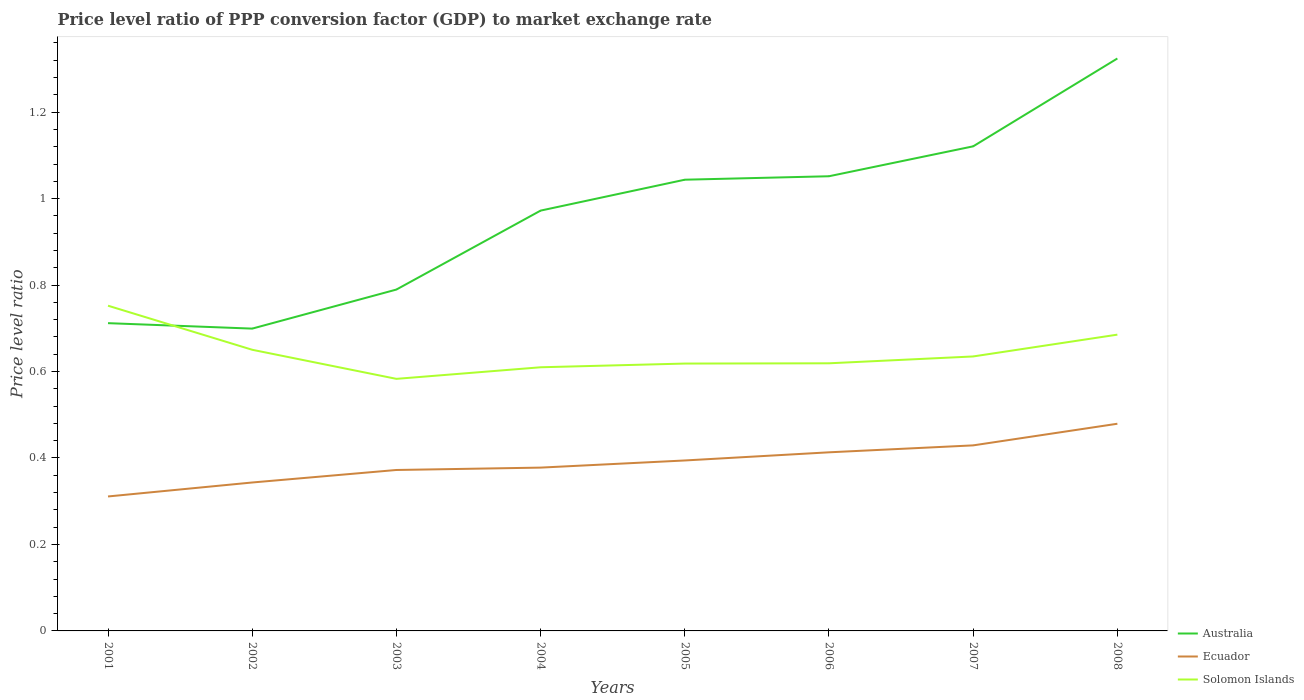How many different coloured lines are there?
Provide a succinct answer. 3. Does the line corresponding to Australia intersect with the line corresponding to Ecuador?
Offer a very short reply. No. Across all years, what is the maximum price level ratio in Ecuador?
Give a very brief answer. 0.31. In which year was the price level ratio in Solomon Islands maximum?
Make the answer very short. 2003. What is the total price level ratio in Ecuador in the graph?
Provide a short and direct response. -0.05. What is the difference between the highest and the second highest price level ratio in Solomon Islands?
Offer a terse response. 0.17. Is the price level ratio in Australia strictly greater than the price level ratio in Ecuador over the years?
Your answer should be very brief. No. Does the graph contain any zero values?
Provide a short and direct response. No. Where does the legend appear in the graph?
Give a very brief answer. Bottom right. How are the legend labels stacked?
Your answer should be very brief. Vertical. What is the title of the graph?
Give a very brief answer. Price level ratio of PPP conversion factor (GDP) to market exchange rate. Does "Hong Kong" appear as one of the legend labels in the graph?
Offer a very short reply. No. What is the label or title of the X-axis?
Ensure brevity in your answer.  Years. What is the label or title of the Y-axis?
Provide a succinct answer. Price level ratio. What is the Price level ratio in Australia in 2001?
Make the answer very short. 0.71. What is the Price level ratio of Ecuador in 2001?
Offer a terse response. 0.31. What is the Price level ratio of Solomon Islands in 2001?
Keep it short and to the point. 0.75. What is the Price level ratio in Australia in 2002?
Your answer should be very brief. 0.7. What is the Price level ratio in Ecuador in 2002?
Your answer should be very brief. 0.34. What is the Price level ratio in Solomon Islands in 2002?
Offer a terse response. 0.65. What is the Price level ratio in Australia in 2003?
Your response must be concise. 0.79. What is the Price level ratio of Ecuador in 2003?
Make the answer very short. 0.37. What is the Price level ratio of Solomon Islands in 2003?
Your response must be concise. 0.58. What is the Price level ratio in Australia in 2004?
Make the answer very short. 0.97. What is the Price level ratio of Ecuador in 2004?
Provide a succinct answer. 0.38. What is the Price level ratio of Solomon Islands in 2004?
Provide a succinct answer. 0.61. What is the Price level ratio of Australia in 2005?
Keep it short and to the point. 1.04. What is the Price level ratio of Ecuador in 2005?
Provide a succinct answer. 0.39. What is the Price level ratio in Solomon Islands in 2005?
Give a very brief answer. 0.62. What is the Price level ratio of Australia in 2006?
Provide a succinct answer. 1.05. What is the Price level ratio of Ecuador in 2006?
Your response must be concise. 0.41. What is the Price level ratio of Solomon Islands in 2006?
Keep it short and to the point. 0.62. What is the Price level ratio of Australia in 2007?
Give a very brief answer. 1.12. What is the Price level ratio of Ecuador in 2007?
Keep it short and to the point. 0.43. What is the Price level ratio of Solomon Islands in 2007?
Offer a very short reply. 0.63. What is the Price level ratio of Australia in 2008?
Your answer should be compact. 1.32. What is the Price level ratio in Ecuador in 2008?
Keep it short and to the point. 0.48. What is the Price level ratio of Solomon Islands in 2008?
Offer a very short reply. 0.69. Across all years, what is the maximum Price level ratio of Australia?
Provide a short and direct response. 1.32. Across all years, what is the maximum Price level ratio in Ecuador?
Offer a very short reply. 0.48. Across all years, what is the maximum Price level ratio of Solomon Islands?
Your response must be concise. 0.75. Across all years, what is the minimum Price level ratio in Australia?
Give a very brief answer. 0.7. Across all years, what is the minimum Price level ratio of Ecuador?
Your answer should be compact. 0.31. Across all years, what is the minimum Price level ratio of Solomon Islands?
Make the answer very short. 0.58. What is the total Price level ratio in Australia in the graph?
Your answer should be very brief. 7.71. What is the total Price level ratio of Ecuador in the graph?
Your response must be concise. 3.12. What is the total Price level ratio in Solomon Islands in the graph?
Your response must be concise. 5.15. What is the difference between the Price level ratio of Australia in 2001 and that in 2002?
Your answer should be very brief. 0.01. What is the difference between the Price level ratio of Ecuador in 2001 and that in 2002?
Make the answer very short. -0.03. What is the difference between the Price level ratio of Solomon Islands in 2001 and that in 2002?
Your answer should be very brief. 0.1. What is the difference between the Price level ratio in Australia in 2001 and that in 2003?
Make the answer very short. -0.08. What is the difference between the Price level ratio in Ecuador in 2001 and that in 2003?
Keep it short and to the point. -0.06. What is the difference between the Price level ratio of Solomon Islands in 2001 and that in 2003?
Make the answer very short. 0.17. What is the difference between the Price level ratio in Australia in 2001 and that in 2004?
Your response must be concise. -0.26. What is the difference between the Price level ratio in Ecuador in 2001 and that in 2004?
Your response must be concise. -0.07. What is the difference between the Price level ratio in Solomon Islands in 2001 and that in 2004?
Your answer should be very brief. 0.14. What is the difference between the Price level ratio in Australia in 2001 and that in 2005?
Your answer should be compact. -0.33. What is the difference between the Price level ratio in Ecuador in 2001 and that in 2005?
Your answer should be compact. -0.08. What is the difference between the Price level ratio of Solomon Islands in 2001 and that in 2005?
Provide a short and direct response. 0.13. What is the difference between the Price level ratio in Australia in 2001 and that in 2006?
Offer a terse response. -0.34. What is the difference between the Price level ratio in Ecuador in 2001 and that in 2006?
Provide a succinct answer. -0.1. What is the difference between the Price level ratio in Solomon Islands in 2001 and that in 2006?
Offer a very short reply. 0.13. What is the difference between the Price level ratio in Australia in 2001 and that in 2007?
Ensure brevity in your answer.  -0.41. What is the difference between the Price level ratio in Ecuador in 2001 and that in 2007?
Make the answer very short. -0.12. What is the difference between the Price level ratio of Solomon Islands in 2001 and that in 2007?
Keep it short and to the point. 0.12. What is the difference between the Price level ratio in Australia in 2001 and that in 2008?
Provide a short and direct response. -0.61. What is the difference between the Price level ratio of Ecuador in 2001 and that in 2008?
Keep it short and to the point. -0.17. What is the difference between the Price level ratio in Solomon Islands in 2001 and that in 2008?
Your answer should be very brief. 0.07. What is the difference between the Price level ratio in Australia in 2002 and that in 2003?
Offer a very short reply. -0.09. What is the difference between the Price level ratio of Ecuador in 2002 and that in 2003?
Offer a very short reply. -0.03. What is the difference between the Price level ratio in Solomon Islands in 2002 and that in 2003?
Ensure brevity in your answer.  0.07. What is the difference between the Price level ratio in Australia in 2002 and that in 2004?
Keep it short and to the point. -0.27. What is the difference between the Price level ratio of Ecuador in 2002 and that in 2004?
Make the answer very short. -0.03. What is the difference between the Price level ratio in Solomon Islands in 2002 and that in 2004?
Offer a very short reply. 0.04. What is the difference between the Price level ratio in Australia in 2002 and that in 2005?
Ensure brevity in your answer.  -0.34. What is the difference between the Price level ratio in Ecuador in 2002 and that in 2005?
Ensure brevity in your answer.  -0.05. What is the difference between the Price level ratio in Solomon Islands in 2002 and that in 2005?
Your answer should be compact. 0.03. What is the difference between the Price level ratio of Australia in 2002 and that in 2006?
Provide a succinct answer. -0.35. What is the difference between the Price level ratio of Ecuador in 2002 and that in 2006?
Your answer should be very brief. -0.07. What is the difference between the Price level ratio of Solomon Islands in 2002 and that in 2006?
Make the answer very short. 0.03. What is the difference between the Price level ratio in Australia in 2002 and that in 2007?
Give a very brief answer. -0.42. What is the difference between the Price level ratio in Ecuador in 2002 and that in 2007?
Ensure brevity in your answer.  -0.09. What is the difference between the Price level ratio of Solomon Islands in 2002 and that in 2007?
Offer a terse response. 0.02. What is the difference between the Price level ratio in Australia in 2002 and that in 2008?
Provide a succinct answer. -0.62. What is the difference between the Price level ratio of Ecuador in 2002 and that in 2008?
Ensure brevity in your answer.  -0.14. What is the difference between the Price level ratio of Solomon Islands in 2002 and that in 2008?
Keep it short and to the point. -0.04. What is the difference between the Price level ratio of Australia in 2003 and that in 2004?
Provide a short and direct response. -0.18. What is the difference between the Price level ratio in Ecuador in 2003 and that in 2004?
Your response must be concise. -0.01. What is the difference between the Price level ratio of Solomon Islands in 2003 and that in 2004?
Keep it short and to the point. -0.03. What is the difference between the Price level ratio of Australia in 2003 and that in 2005?
Give a very brief answer. -0.25. What is the difference between the Price level ratio in Ecuador in 2003 and that in 2005?
Keep it short and to the point. -0.02. What is the difference between the Price level ratio in Solomon Islands in 2003 and that in 2005?
Provide a short and direct response. -0.04. What is the difference between the Price level ratio of Australia in 2003 and that in 2006?
Your response must be concise. -0.26. What is the difference between the Price level ratio of Ecuador in 2003 and that in 2006?
Provide a succinct answer. -0.04. What is the difference between the Price level ratio of Solomon Islands in 2003 and that in 2006?
Offer a very short reply. -0.04. What is the difference between the Price level ratio in Australia in 2003 and that in 2007?
Provide a succinct answer. -0.33. What is the difference between the Price level ratio of Ecuador in 2003 and that in 2007?
Offer a terse response. -0.06. What is the difference between the Price level ratio of Solomon Islands in 2003 and that in 2007?
Offer a terse response. -0.05. What is the difference between the Price level ratio in Australia in 2003 and that in 2008?
Keep it short and to the point. -0.53. What is the difference between the Price level ratio in Ecuador in 2003 and that in 2008?
Ensure brevity in your answer.  -0.11. What is the difference between the Price level ratio in Solomon Islands in 2003 and that in 2008?
Keep it short and to the point. -0.1. What is the difference between the Price level ratio of Australia in 2004 and that in 2005?
Give a very brief answer. -0.07. What is the difference between the Price level ratio of Ecuador in 2004 and that in 2005?
Give a very brief answer. -0.02. What is the difference between the Price level ratio in Solomon Islands in 2004 and that in 2005?
Your answer should be very brief. -0.01. What is the difference between the Price level ratio of Australia in 2004 and that in 2006?
Give a very brief answer. -0.08. What is the difference between the Price level ratio of Ecuador in 2004 and that in 2006?
Give a very brief answer. -0.04. What is the difference between the Price level ratio of Solomon Islands in 2004 and that in 2006?
Give a very brief answer. -0.01. What is the difference between the Price level ratio of Australia in 2004 and that in 2007?
Give a very brief answer. -0.15. What is the difference between the Price level ratio in Ecuador in 2004 and that in 2007?
Give a very brief answer. -0.05. What is the difference between the Price level ratio of Solomon Islands in 2004 and that in 2007?
Make the answer very short. -0.03. What is the difference between the Price level ratio in Australia in 2004 and that in 2008?
Give a very brief answer. -0.35. What is the difference between the Price level ratio of Ecuador in 2004 and that in 2008?
Your response must be concise. -0.1. What is the difference between the Price level ratio in Solomon Islands in 2004 and that in 2008?
Provide a short and direct response. -0.08. What is the difference between the Price level ratio in Australia in 2005 and that in 2006?
Offer a terse response. -0.01. What is the difference between the Price level ratio of Ecuador in 2005 and that in 2006?
Provide a short and direct response. -0.02. What is the difference between the Price level ratio in Solomon Islands in 2005 and that in 2006?
Ensure brevity in your answer.  -0. What is the difference between the Price level ratio of Australia in 2005 and that in 2007?
Offer a very short reply. -0.08. What is the difference between the Price level ratio in Ecuador in 2005 and that in 2007?
Make the answer very short. -0.03. What is the difference between the Price level ratio of Solomon Islands in 2005 and that in 2007?
Your answer should be very brief. -0.02. What is the difference between the Price level ratio of Australia in 2005 and that in 2008?
Offer a terse response. -0.28. What is the difference between the Price level ratio in Ecuador in 2005 and that in 2008?
Ensure brevity in your answer.  -0.08. What is the difference between the Price level ratio of Solomon Islands in 2005 and that in 2008?
Keep it short and to the point. -0.07. What is the difference between the Price level ratio of Australia in 2006 and that in 2007?
Ensure brevity in your answer.  -0.07. What is the difference between the Price level ratio in Ecuador in 2006 and that in 2007?
Give a very brief answer. -0.02. What is the difference between the Price level ratio in Solomon Islands in 2006 and that in 2007?
Your answer should be compact. -0.02. What is the difference between the Price level ratio of Australia in 2006 and that in 2008?
Provide a short and direct response. -0.27. What is the difference between the Price level ratio in Ecuador in 2006 and that in 2008?
Make the answer very short. -0.07. What is the difference between the Price level ratio of Solomon Islands in 2006 and that in 2008?
Make the answer very short. -0.07. What is the difference between the Price level ratio in Australia in 2007 and that in 2008?
Provide a short and direct response. -0.2. What is the difference between the Price level ratio in Solomon Islands in 2007 and that in 2008?
Offer a terse response. -0.05. What is the difference between the Price level ratio in Australia in 2001 and the Price level ratio in Ecuador in 2002?
Give a very brief answer. 0.37. What is the difference between the Price level ratio in Australia in 2001 and the Price level ratio in Solomon Islands in 2002?
Provide a succinct answer. 0.06. What is the difference between the Price level ratio of Ecuador in 2001 and the Price level ratio of Solomon Islands in 2002?
Your answer should be very brief. -0.34. What is the difference between the Price level ratio in Australia in 2001 and the Price level ratio in Ecuador in 2003?
Make the answer very short. 0.34. What is the difference between the Price level ratio in Australia in 2001 and the Price level ratio in Solomon Islands in 2003?
Give a very brief answer. 0.13. What is the difference between the Price level ratio in Ecuador in 2001 and the Price level ratio in Solomon Islands in 2003?
Offer a terse response. -0.27. What is the difference between the Price level ratio of Australia in 2001 and the Price level ratio of Ecuador in 2004?
Offer a terse response. 0.33. What is the difference between the Price level ratio of Australia in 2001 and the Price level ratio of Solomon Islands in 2004?
Make the answer very short. 0.1. What is the difference between the Price level ratio in Ecuador in 2001 and the Price level ratio in Solomon Islands in 2004?
Provide a short and direct response. -0.3. What is the difference between the Price level ratio in Australia in 2001 and the Price level ratio in Ecuador in 2005?
Offer a terse response. 0.32. What is the difference between the Price level ratio in Australia in 2001 and the Price level ratio in Solomon Islands in 2005?
Provide a succinct answer. 0.09. What is the difference between the Price level ratio of Ecuador in 2001 and the Price level ratio of Solomon Islands in 2005?
Give a very brief answer. -0.31. What is the difference between the Price level ratio of Australia in 2001 and the Price level ratio of Ecuador in 2006?
Offer a very short reply. 0.3. What is the difference between the Price level ratio of Australia in 2001 and the Price level ratio of Solomon Islands in 2006?
Your answer should be compact. 0.09. What is the difference between the Price level ratio of Ecuador in 2001 and the Price level ratio of Solomon Islands in 2006?
Your answer should be compact. -0.31. What is the difference between the Price level ratio of Australia in 2001 and the Price level ratio of Ecuador in 2007?
Provide a succinct answer. 0.28. What is the difference between the Price level ratio of Australia in 2001 and the Price level ratio of Solomon Islands in 2007?
Your answer should be very brief. 0.08. What is the difference between the Price level ratio in Ecuador in 2001 and the Price level ratio in Solomon Islands in 2007?
Give a very brief answer. -0.32. What is the difference between the Price level ratio in Australia in 2001 and the Price level ratio in Ecuador in 2008?
Ensure brevity in your answer.  0.23. What is the difference between the Price level ratio of Australia in 2001 and the Price level ratio of Solomon Islands in 2008?
Your answer should be very brief. 0.03. What is the difference between the Price level ratio of Ecuador in 2001 and the Price level ratio of Solomon Islands in 2008?
Your response must be concise. -0.37. What is the difference between the Price level ratio in Australia in 2002 and the Price level ratio in Ecuador in 2003?
Make the answer very short. 0.33. What is the difference between the Price level ratio in Australia in 2002 and the Price level ratio in Solomon Islands in 2003?
Offer a terse response. 0.12. What is the difference between the Price level ratio in Ecuador in 2002 and the Price level ratio in Solomon Islands in 2003?
Your answer should be very brief. -0.24. What is the difference between the Price level ratio in Australia in 2002 and the Price level ratio in Ecuador in 2004?
Offer a terse response. 0.32. What is the difference between the Price level ratio in Australia in 2002 and the Price level ratio in Solomon Islands in 2004?
Provide a short and direct response. 0.09. What is the difference between the Price level ratio in Ecuador in 2002 and the Price level ratio in Solomon Islands in 2004?
Give a very brief answer. -0.27. What is the difference between the Price level ratio in Australia in 2002 and the Price level ratio in Ecuador in 2005?
Your answer should be very brief. 0.3. What is the difference between the Price level ratio of Australia in 2002 and the Price level ratio of Solomon Islands in 2005?
Offer a terse response. 0.08. What is the difference between the Price level ratio in Ecuador in 2002 and the Price level ratio in Solomon Islands in 2005?
Your response must be concise. -0.28. What is the difference between the Price level ratio of Australia in 2002 and the Price level ratio of Ecuador in 2006?
Offer a terse response. 0.29. What is the difference between the Price level ratio of Australia in 2002 and the Price level ratio of Solomon Islands in 2006?
Offer a very short reply. 0.08. What is the difference between the Price level ratio of Ecuador in 2002 and the Price level ratio of Solomon Islands in 2006?
Offer a very short reply. -0.28. What is the difference between the Price level ratio of Australia in 2002 and the Price level ratio of Ecuador in 2007?
Ensure brevity in your answer.  0.27. What is the difference between the Price level ratio in Australia in 2002 and the Price level ratio in Solomon Islands in 2007?
Offer a terse response. 0.06. What is the difference between the Price level ratio of Ecuador in 2002 and the Price level ratio of Solomon Islands in 2007?
Ensure brevity in your answer.  -0.29. What is the difference between the Price level ratio of Australia in 2002 and the Price level ratio of Ecuador in 2008?
Offer a very short reply. 0.22. What is the difference between the Price level ratio in Australia in 2002 and the Price level ratio in Solomon Islands in 2008?
Provide a succinct answer. 0.01. What is the difference between the Price level ratio in Ecuador in 2002 and the Price level ratio in Solomon Islands in 2008?
Offer a very short reply. -0.34. What is the difference between the Price level ratio of Australia in 2003 and the Price level ratio of Ecuador in 2004?
Your response must be concise. 0.41. What is the difference between the Price level ratio in Australia in 2003 and the Price level ratio in Solomon Islands in 2004?
Offer a terse response. 0.18. What is the difference between the Price level ratio in Ecuador in 2003 and the Price level ratio in Solomon Islands in 2004?
Keep it short and to the point. -0.24. What is the difference between the Price level ratio of Australia in 2003 and the Price level ratio of Ecuador in 2005?
Provide a short and direct response. 0.4. What is the difference between the Price level ratio of Australia in 2003 and the Price level ratio of Solomon Islands in 2005?
Your response must be concise. 0.17. What is the difference between the Price level ratio of Ecuador in 2003 and the Price level ratio of Solomon Islands in 2005?
Your response must be concise. -0.25. What is the difference between the Price level ratio in Australia in 2003 and the Price level ratio in Ecuador in 2006?
Ensure brevity in your answer.  0.38. What is the difference between the Price level ratio of Australia in 2003 and the Price level ratio of Solomon Islands in 2006?
Ensure brevity in your answer.  0.17. What is the difference between the Price level ratio of Ecuador in 2003 and the Price level ratio of Solomon Islands in 2006?
Keep it short and to the point. -0.25. What is the difference between the Price level ratio of Australia in 2003 and the Price level ratio of Ecuador in 2007?
Keep it short and to the point. 0.36. What is the difference between the Price level ratio of Australia in 2003 and the Price level ratio of Solomon Islands in 2007?
Provide a succinct answer. 0.15. What is the difference between the Price level ratio of Ecuador in 2003 and the Price level ratio of Solomon Islands in 2007?
Offer a very short reply. -0.26. What is the difference between the Price level ratio in Australia in 2003 and the Price level ratio in Ecuador in 2008?
Offer a very short reply. 0.31. What is the difference between the Price level ratio in Australia in 2003 and the Price level ratio in Solomon Islands in 2008?
Ensure brevity in your answer.  0.1. What is the difference between the Price level ratio in Ecuador in 2003 and the Price level ratio in Solomon Islands in 2008?
Offer a very short reply. -0.31. What is the difference between the Price level ratio in Australia in 2004 and the Price level ratio in Ecuador in 2005?
Your answer should be very brief. 0.58. What is the difference between the Price level ratio in Australia in 2004 and the Price level ratio in Solomon Islands in 2005?
Provide a succinct answer. 0.35. What is the difference between the Price level ratio of Ecuador in 2004 and the Price level ratio of Solomon Islands in 2005?
Give a very brief answer. -0.24. What is the difference between the Price level ratio of Australia in 2004 and the Price level ratio of Ecuador in 2006?
Your response must be concise. 0.56. What is the difference between the Price level ratio of Australia in 2004 and the Price level ratio of Solomon Islands in 2006?
Offer a terse response. 0.35. What is the difference between the Price level ratio in Ecuador in 2004 and the Price level ratio in Solomon Islands in 2006?
Provide a short and direct response. -0.24. What is the difference between the Price level ratio in Australia in 2004 and the Price level ratio in Ecuador in 2007?
Offer a very short reply. 0.54. What is the difference between the Price level ratio of Australia in 2004 and the Price level ratio of Solomon Islands in 2007?
Provide a succinct answer. 0.34. What is the difference between the Price level ratio of Ecuador in 2004 and the Price level ratio of Solomon Islands in 2007?
Your response must be concise. -0.26. What is the difference between the Price level ratio of Australia in 2004 and the Price level ratio of Ecuador in 2008?
Give a very brief answer. 0.49. What is the difference between the Price level ratio of Australia in 2004 and the Price level ratio of Solomon Islands in 2008?
Provide a succinct answer. 0.29. What is the difference between the Price level ratio in Ecuador in 2004 and the Price level ratio in Solomon Islands in 2008?
Provide a succinct answer. -0.31. What is the difference between the Price level ratio of Australia in 2005 and the Price level ratio of Ecuador in 2006?
Ensure brevity in your answer.  0.63. What is the difference between the Price level ratio of Australia in 2005 and the Price level ratio of Solomon Islands in 2006?
Give a very brief answer. 0.42. What is the difference between the Price level ratio in Ecuador in 2005 and the Price level ratio in Solomon Islands in 2006?
Make the answer very short. -0.22. What is the difference between the Price level ratio in Australia in 2005 and the Price level ratio in Ecuador in 2007?
Make the answer very short. 0.61. What is the difference between the Price level ratio of Australia in 2005 and the Price level ratio of Solomon Islands in 2007?
Provide a short and direct response. 0.41. What is the difference between the Price level ratio of Ecuador in 2005 and the Price level ratio of Solomon Islands in 2007?
Your response must be concise. -0.24. What is the difference between the Price level ratio in Australia in 2005 and the Price level ratio in Ecuador in 2008?
Ensure brevity in your answer.  0.56. What is the difference between the Price level ratio of Australia in 2005 and the Price level ratio of Solomon Islands in 2008?
Your answer should be compact. 0.36. What is the difference between the Price level ratio in Ecuador in 2005 and the Price level ratio in Solomon Islands in 2008?
Provide a short and direct response. -0.29. What is the difference between the Price level ratio in Australia in 2006 and the Price level ratio in Ecuador in 2007?
Keep it short and to the point. 0.62. What is the difference between the Price level ratio of Australia in 2006 and the Price level ratio of Solomon Islands in 2007?
Your response must be concise. 0.42. What is the difference between the Price level ratio in Ecuador in 2006 and the Price level ratio in Solomon Islands in 2007?
Your answer should be very brief. -0.22. What is the difference between the Price level ratio in Australia in 2006 and the Price level ratio in Ecuador in 2008?
Offer a very short reply. 0.57. What is the difference between the Price level ratio in Australia in 2006 and the Price level ratio in Solomon Islands in 2008?
Provide a succinct answer. 0.37. What is the difference between the Price level ratio of Ecuador in 2006 and the Price level ratio of Solomon Islands in 2008?
Keep it short and to the point. -0.27. What is the difference between the Price level ratio of Australia in 2007 and the Price level ratio of Ecuador in 2008?
Give a very brief answer. 0.64. What is the difference between the Price level ratio of Australia in 2007 and the Price level ratio of Solomon Islands in 2008?
Give a very brief answer. 0.44. What is the difference between the Price level ratio in Ecuador in 2007 and the Price level ratio in Solomon Islands in 2008?
Offer a terse response. -0.26. What is the average Price level ratio of Australia per year?
Give a very brief answer. 0.96. What is the average Price level ratio of Ecuador per year?
Provide a short and direct response. 0.39. What is the average Price level ratio in Solomon Islands per year?
Offer a terse response. 0.64. In the year 2001, what is the difference between the Price level ratio of Australia and Price level ratio of Ecuador?
Offer a terse response. 0.4. In the year 2001, what is the difference between the Price level ratio of Australia and Price level ratio of Solomon Islands?
Provide a short and direct response. -0.04. In the year 2001, what is the difference between the Price level ratio in Ecuador and Price level ratio in Solomon Islands?
Make the answer very short. -0.44. In the year 2002, what is the difference between the Price level ratio of Australia and Price level ratio of Ecuador?
Your answer should be very brief. 0.36. In the year 2002, what is the difference between the Price level ratio in Australia and Price level ratio in Solomon Islands?
Provide a succinct answer. 0.05. In the year 2002, what is the difference between the Price level ratio in Ecuador and Price level ratio in Solomon Islands?
Your response must be concise. -0.31. In the year 2003, what is the difference between the Price level ratio of Australia and Price level ratio of Ecuador?
Keep it short and to the point. 0.42. In the year 2003, what is the difference between the Price level ratio of Australia and Price level ratio of Solomon Islands?
Your response must be concise. 0.21. In the year 2003, what is the difference between the Price level ratio in Ecuador and Price level ratio in Solomon Islands?
Provide a succinct answer. -0.21. In the year 2004, what is the difference between the Price level ratio in Australia and Price level ratio in Ecuador?
Offer a very short reply. 0.59. In the year 2004, what is the difference between the Price level ratio of Australia and Price level ratio of Solomon Islands?
Give a very brief answer. 0.36. In the year 2004, what is the difference between the Price level ratio in Ecuador and Price level ratio in Solomon Islands?
Your answer should be compact. -0.23. In the year 2005, what is the difference between the Price level ratio in Australia and Price level ratio in Ecuador?
Give a very brief answer. 0.65. In the year 2005, what is the difference between the Price level ratio of Australia and Price level ratio of Solomon Islands?
Keep it short and to the point. 0.43. In the year 2005, what is the difference between the Price level ratio in Ecuador and Price level ratio in Solomon Islands?
Give a very brief answer. -0.22. In the year 2006, what is the difference between the Price level ratio in Australia and Price level ratio in Ecuador?
Make the answer very short. 0.64. In the year 2006, what is the difference between the Price level ratio of Australia and Price level ratio of Solomon Islands?
Offer a very short reply. 0.43. In the year 2006, what is the difference between the Price level ratio in Ecuador and Price level ratio in Solomon Islands?
Offer a terse response. -0.21. In the year 2007, what is the difference between the Price level ratio in Australia and Price level ratio in Ecuador?
Your answer should be compact. 0.69. In the year 2007, what is the difference between the Price level ratio in Australia and Price level ratio in Solomon Islands?
Ensure brevity in your answer.  0.49. In the year 2007, what is the difference between the Price level ratio in Ecuador and Price level ratio in Solomon Islands?
Provide a succinct answer. -0.21. In the year 2008, what is the difference between the Price level ratio in Australia and Price level ratio in Ecuador?
Offer a terse response. 0.84. In the year 2008, what is the difference between the Price level ratio in Australia and Price level ratio in Solomon Islands?
Offer a very short reply. 0.64. In the year 2008, what is the difference between the Price level ratio in Ecuador and Price level ratio in Solomon Islands?
Make the answer very short. -0.21. What is the ratio of the Price level ratio of Ecuador in 2001 to that in 2002?
Give a very brief answer. 0.91. What is the ratio of the Price level ratio in Solomon Islands in 2001 to that in 2002?
Ensure brevity in your answer.  1.16. What is the ratio of the Price level ratio in Australia in 2001 to that in 2003?
Your response must be concise. 0.9. What is the ratio of the Price level ratio of Ecuador in 2001 to that in 2003?
Ensure brevity in your answer.  0.84. What is the ratio of the Price level ratio of Solomon Islands in 2001 to that in 2003?
Ensure brevity in your answer.  1.29. What is the ratio of the Price level ratio of Australia in 2001 to that in 2004?
Keep it short and to the point. 0.73. What is the ratio of the Price level ratio in Ecuador in 2001 to that in 2004?
Offer a terse response. 0.82. What is the ratio of the Price level ratio in Solomon Islands in 2001 to that in 2004?
Give a very brief answer. 1.23. What is the ratio of the Price level ratio in Australia in 2001 to that in 2005?
Ensure brevity in your answer.  0.68. What is the ratio of the Price level ratio in Ecuador in 2001 to that in 2005?
Your answer should be very brief. 0.79. What is the ratio of the Price level ratio of Solomon Islands in 2001 to that in 2005?
Your answer should be very brief. 1.22. What is the ratio of the Price level ratio of Australia in 2001 to that in 2006?
Provide a short and direct response. 0.68. What is the ratio of the Price level ratio in Ecuador in 2001 to that in 2006?
Offer a very short reply. 0.75. What is the ratio of the Price level ratio in Solomon Islands in 2001 to that in 2006?
Provide a short and direct response. 1.22. What is the ratio of the Price level ratio in Australia in 2001 to that in 2007?
Your answer should be very brief. 0.64. What is the ratio of the Price level ratio of Ecuador in 2001 to that in 2007?
Provide a short and direct response. 0.72. What is the ratio of the Price level ratio of Solomon Islands in 2001 to that in 2007?
Your response must be concise. 1.18. What is the ratio of the Price level ratio in Australia in 2001 to that in 2008?
Your answer should be very brief. 0.54. What is the ratio of the Price level ratio in Ecuador in 2001 to that in 2008?
Ensure brevity in your answer.  0.65. What is the ratio of the Price level ratio of Solomon Islands in 2001 to that in 2008?
Give a very brief answer. 1.1. What is the ratio of the Price level ratio in Australia in 2002 to that in 2003?
Your answer should be very brief. 0.89. What is the ratio of the Price level ratio of Ecuador in 2002 to that in 2003?
Your response must be concise. 0.92. What is the ratio of the Price level ratio of Solomon Islands in 2002 to that in 2003?
Offer a terse response. 1.12. What is the ratio of the Price level ratio in Australia in 2002 to that in 2004?
Provide a short and direct response. 0.72. What is the ratio of the Price level ratio in Ecuador in 2002 to that in 2004?
Give a very brief answer. 0.91. What is the ratio of the Price level ratio in Solomon Islands in 2002 to that in 2004?
Your response must be concise. 1.07. What is the ratio of the Price level ratio in Australia in 2002 to that in 2005?
Give a very brief answer. 0.67. What is the ratio of the Price level ratio of Ecuador in 2002 to that in 2005?
Offer a very short reply. 0.87. What is the ratio of the Price level ratio in Solomon Islands in 2002 to that in 2005?
Make the answer very short. 1.05. What is the ratio of the Price level ratio in Australia in 2002 to that in 2006?
Offer a terse response. 0.66. What is the ratio of the Price level ratio in Ecuador in 2002 to that in 2006?
Ensure brevity in your answer.  0.83. What is the ratio of the Price level ratio of Solomon Islands in 2002 to that in 2006?
Make the answer very short. 1.05. What is the ratio of the Price level ratio of Australia in 2002 to that in 2007?
Make the answer very short. 0.62. What is the ratio of the Price level ratio in Ecuador in 2002 to that in 2007?
Provide a succinct answer. 0.8. What is the ratio of the Price level ratio of Solomon Islands in 2002 to that in 2007?
Your answer should be compact. 1.02. What is the ratio of the Price level ratio of Australia in 2002 to that in 2008?
Provide a short and direct response. 0.53. What is the ratio of the Price level ratio of Ecuador in 2002 to that in 2008?
Make the answer very short. 0.72. What is the ratio of the Price level ratio of Solomon Islands in 2002 to that in 2008?
Keep it short and to the point. 0.95. What is the ratio of the Price level ratio of Australia in 2003 to that in 2004?
Offer a terse response. 0.81. What is the ratio of the Price level ratio in Ecuador in 2003 to that in 2004?
Offer a terse response. 0.99. What is the ratio of the Price level ratio of Solomon Islands in 2003 to that in 2004?
Provide a short and direct response. 0.96. What is the ratio of the Price level ratio in Australia in 2003 to that in 2005?
Keep it short and to the point. 0.76. What is the ratio of the Price level ratio in Ecuador in 2003 to that in 2005?
Offer a very short reply. 0.94. What is the ratio of the Price level ratio in Solomon Islands in 2003 to that in 2005?
Your answer should be compact. 0.94. What is the ratio of the Price level ratio of Australia in 2003 to that in 2006?
Your answer should be compact. 0.75. What is the ratio of the Price level ratio of Ecuador in 2003 to that in 2006?
Your answer should be compact. 0.9. What is the ratio of the Price level ratio in Solomon Islands in 2003 to that in 2006?
Offer a terse response. 0.94. What is the ratio of the Price level ratio in Australia in 2003 to that in 2007?
Keep it short and to the point. 0.7. What is the ratio of the Price level ratio of Ecuador in 2003 to that in 2007?
Provide a succinct answer. 0.87. What is the ratio of the Price level ratio of Solomon Islands in 2003 to that in 2007?
Your answer should be very brief. 0.92. What is the ratio of the Price level ratio in Australia in 2003 to that in 2008?
Your response must be concise. 0.6. What is the ratio of the Price level ratio of Ecuador in 2003 to that in 2008?
Keep it short and to the point. 0.78. What is the ratio of the Price level ratio of Solomon Islands in 2003 to that in 2008?
Your answer should be very brief. 0.85. What is the ratio of the Price level ratio in Australia in 2004 to that in 2005?
Ensure brevity in your answer.  0.93. What is the ratio of the Price level ratio in Ecuador in 2004 to that in 2005?
Your answer should be very brief. 0.96. What is the ratio of the Price level ratio in Solomon Islands in 2004 to that in 2005?
Offer a terse response. 0.99. What is the ratio of the Price level ratio in Australia in 2004 to that in 2006?
Ensure brevity in your answer.  0.92. What is the ratio of the Price level ratio of Ecuador in 2004 to that in 2006?
Your response must be concise. 0.91. What is the ratio of the Price level ratio of Solomon Islands in 2004 to that in 2006?
Your response must be concise. 0.99. What is the ratio of the Price level ratio of Australia in 2004 to that in 2007?
Provide a short and direct response. 0.87. What is the ratio of the Price level ratio of Ecuador in 2004 to that in 2007?
Your answer should be compact. 0.88. What is the ratio of the Price level ratio in Solomon Islands in 2004 to that in 2007?
Offer a very short reply. 0.96. What is the ratio of the Price level ratio in Australia in 2004 to that in 2008?
Offer a terse response. 0.73. What is the ratio of the Price level ratio of Ecuador in 2004 to that in 2008?
Make the answer very short. 0.79. What is the ratio of the Price level ratio in Solomon Islands in 2004 to that in 2008?
Keep it short and to the point. 0.89. What is the ratio of the Price level ratio of Australia in 2005 to that in 2006?
Keep it short and to the point. 0.99. What is the ratio of the Price level ratio in Ecuador in 2005 to that in 2006?
Your answer should be very brief. 0.95. What is the ratio of the Price level ratio in Australia in 2005 to that in 2007?
Your answer should be very brief. 0.93. What is the ratio of the Price level ratio of Ecuador in 2005 to that in 2007?
Provide a short and direct response. 0.92. What is the ratio of the Price level ratio in Solomon Islands in 2005 to that in 2007?
Your answer should be very brief. 0.97. What is the ratio of the Price level ratio of Australia in 2005 to that in 2008?
Your answer should be very brief. 0.79. What is the ratio of the Price level ratio of Ecuador in 2005 to that in 2008?
Give a very brief answer. 0.82. What is the ratio of the Price level ratio of Solomon Islands in 2005 to that in 2008?
Your answer should be very brief. 0.9. What is the ratio of the Price level ratio of Australia in 2006 to that in 2007?
Your answer should be compact. 0.94. What is the ratio of the Price level ratio of Ecuador in 2006 to that in 2007?
Your response must be concise. 0.96. What is the ratio of the Price level ratio in Australia in 2006 to that in 2008?
Your answer should be compact. 0.79. What is the ratio of the Price level ratio of Ecuador in 2006 to that in 2008?
Your answer should be very brief. 0.86. What is the ratio of the Price level ratio in Solomon Islands in 2006 to that in 2008?
Your response must be concise. 0.9. What is the ratio of the Price level ratio in Australia in 2007 to that in 2008?
Ensure brevity in your answer.  0.85. What is the ratio of the Price level ratio of Ecuador in 2007 to that in 2008?
Make the answer very short. 0.9. What is the ratio of the Price level ratio in Solomon Islands in 2007 to that in 2008?
Offer a terse response. 0.93. What is the difference between the highest and the second highest Price level ratio in Australia?
Give a very brief answer. 0.2. What is the difference between the highest and the second highest Price level ratio of Ecuador?
Provide a short and direct response. 0.05. What is the difference between the highest and the second highest Price level ratio of Solomon Islands?
Provide a short and direct response. 0.07. What is the difference between the highest and the lowest Price level ratio in Australia?
Provide a succinct answer. 0.62. What is the difference between the highest and the lowest Price level ratio of Ecuador?
Your answer should be very brief. 0.17. What is the difference between the highest and the lowest Price level ratio of Solomon Islands?
Keep it short and to the point. 0.17. 